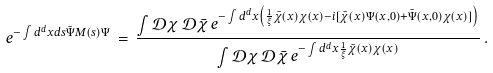Convert formula to latex. <formula><loc_0><loc_0><loc_500><loc_500>e ^ { - \int d ^ { d } x d s { \bar { \Psi } } M ( s ) \Psi } \, = \, \frac { \int { \mathcal { D } } \chi \, { \mathcal { D } } { \bar { \chi } } \, e ^ { - \int d ^ { d } x \left ( \frac { 1 } { \xi } { \bar { \chi } } ( x ) \chi ( x ) - i [ { \bar { \chi } } ( x ) \Psi ( x , 0 ) + { \bar { \Psi } } ( x , 0 ) \chi ( x ) ] \right ) } } { \int { \mathcal { D } } \chi \, { \mathcal { D } } { \bar { \chi } } \, e ^ { - \int d ^ { d } x \frac { 1 } { \xi } { \bar { \chi } } ( x ) \chi ( x ) } } \, .</formula> 